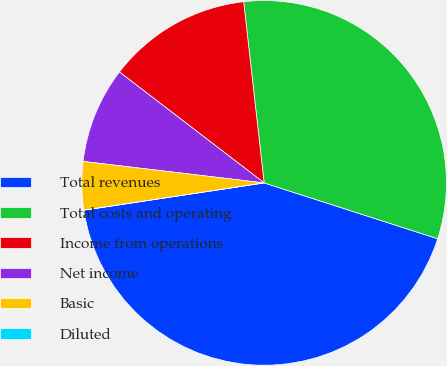Convert chart. <chart><loc_0><loc_0><loc_500><loc_500><pie_chart><fcel>Total revenues<fcel>Total costs and operating<fcel>Income from operations<fcel>Net income<fcel>Basic<fcel>Diluted<nl><fcel>42.66%<fcel>31.75%<fcel>12.8%<fcel>8.53%<fcel>4.27%<fcel>0.0%<nl></chart> 